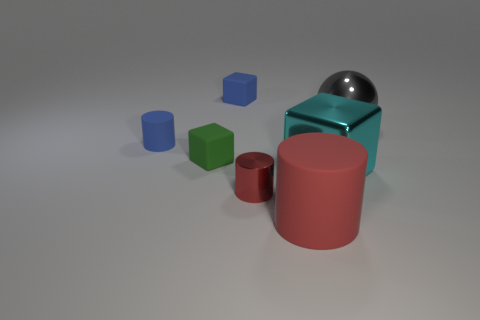Is there anything else that is the same material as the green cube?
Give a very brief answer. Yes. What is the shape of the big gray object?
Provide a short and direct response. Sphere. What is the shape of the object in front of the red cylinder left of the big rubber cylinder?
Your response must be concise. Cylinder. Are the gray object that is right of the red shiny cylinder and the tiny green object made of the same material?
Make the answer very short. No. How many gray things are either metal cubes or large cylinders?
Offer a very short reply. 0. Is there a large metallic object that has the same color as the big cylinder?
Your answer should be compact. No. Are there any green blocks that have the same material as the tiny blue cylinder?
Offer a very short reply. Yes. What shape is the object that is both in front of the tiny green thing and behind the small red cylinder?
Your answer should be very brief. Cube. How many big objects are either blue rubber cylinders or yellow metal spheres?
Provide a succinct answer. 0. What is the big cube made of?
Provide a succinct answer. Metal. 